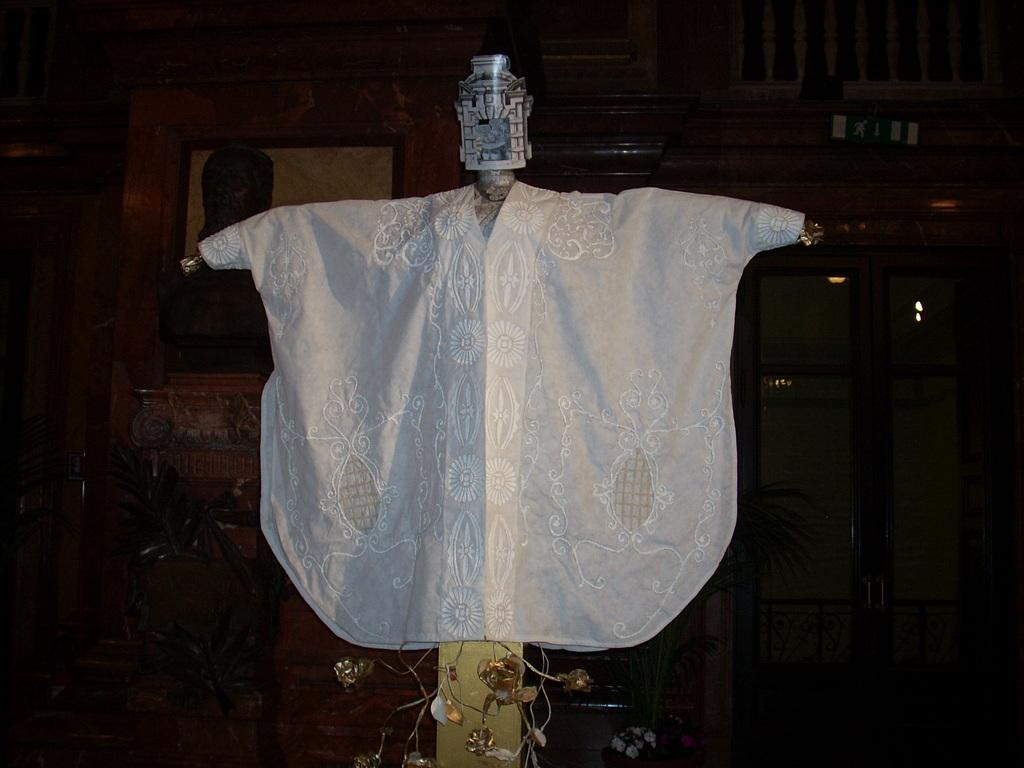What is attached to the pole in the image? There is a cloth and an object attached to the pole in the image. What can be seen in the background of the image? There are potted plants, a photo frame, a cupboard, and a wall visible in the background of the image. What type of laborer is working on the icicle in the image? There is no laborer or icicle present in the image. 